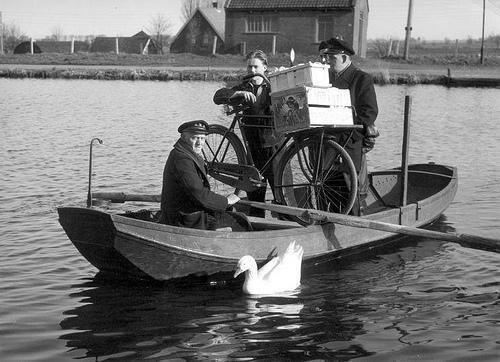How many people can you see?
Give a very brief answer. 3. 